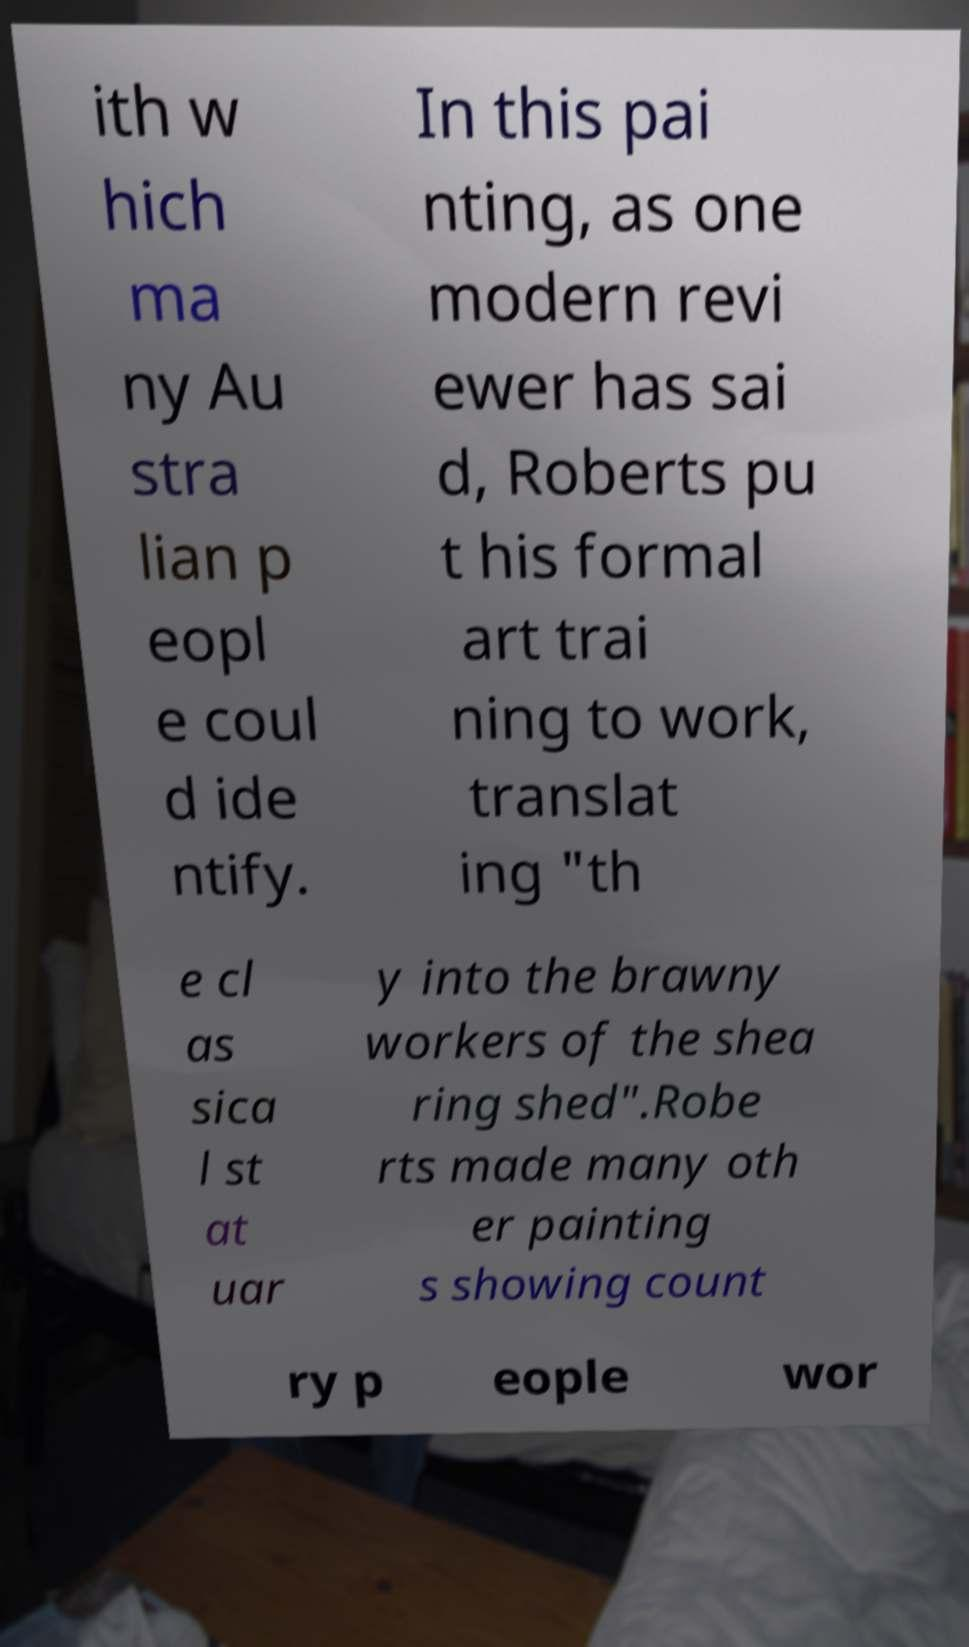There's text embedded in this image that I need extracted. Can you transcribe it verbatim? ith w hich ma ny Au stra lian p eopl e coul d ide ntify. In this pai nting, as one modern revi ewer has sai d, Roberts pu t his formal art trai ning to work, translat ing "th e cl as sica l st at uar y into the brawny workers of the shea ring shed".Robe rts made many oth er painting s showing count ry p eople wor 